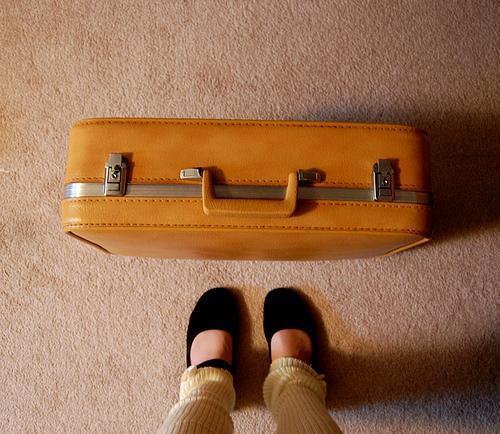How many shoes are shown?
Give a very brief answer. 2. 